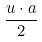Convert formula to latex. <formula><loc_0><loc_0><loc_500><loc_500>\frac { u \cdot a } { 2 }</formula> 